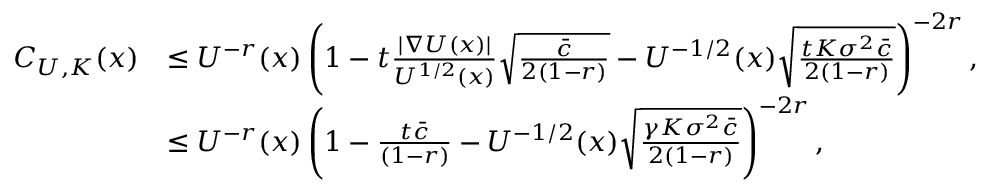Convert formula to latex. <formula><loc_0><loc_0><loc_500><loc_500>\begin{array} { r l } { C _ { U , K } ( x ) } & { \leq U ^ { - r } ( x ) \left ( 1 - t \frac { | \nabla U ( x ) | } { U ^ { 1 / 2 } ( x ) } \sqrt { \frac { \bar { c } } { 2 ( 1 - r ) } } - U ^ { - 1 / 2 } ( x ) \sqrt { \frac { t K \sigma ^ { 2 } \bar { c } } { 2 ( 1 - r ) } } \right ) ^ { - 2 r } , } \\ & { \leq U ^ { - r } ( x ) \left ( 1 - \frac { t \bar { c } } { ( 1 - r ) } - U ^ { - 1 / 2 } ( x ) \sqrt { \frac { \gamma K \sigma ^ { 2 } \bar { c } } { 2 ( 1 - r ) } } \right ) ^ { - 2 r } , } \end{array}</formula> 